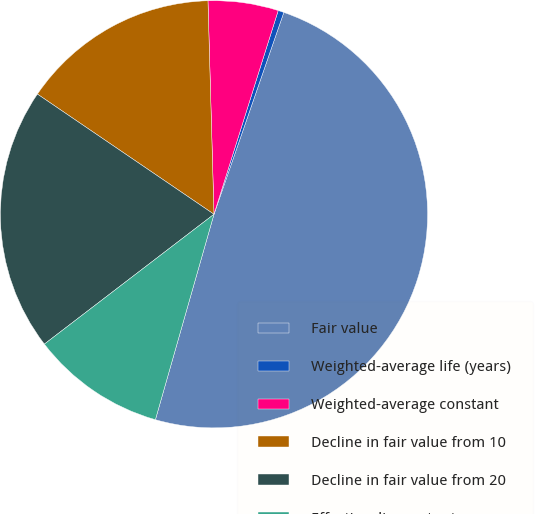<chart> <loc_0><loc_0><loc_500><loc_500><pie_chart><fcel>Fair value<fcel>Weighted-average life (years)<fcel>Weighted-average constant<fcel>Decline in fair value from 10<fcel>Decline in fair value from 20<fcel>Effective discount rate<nl><fcel>49.12%<fcel>0.44%<fcel>5.31%<fcel>15.04%<fcel>19.91%<fcel>10.18%<nl></chart> 